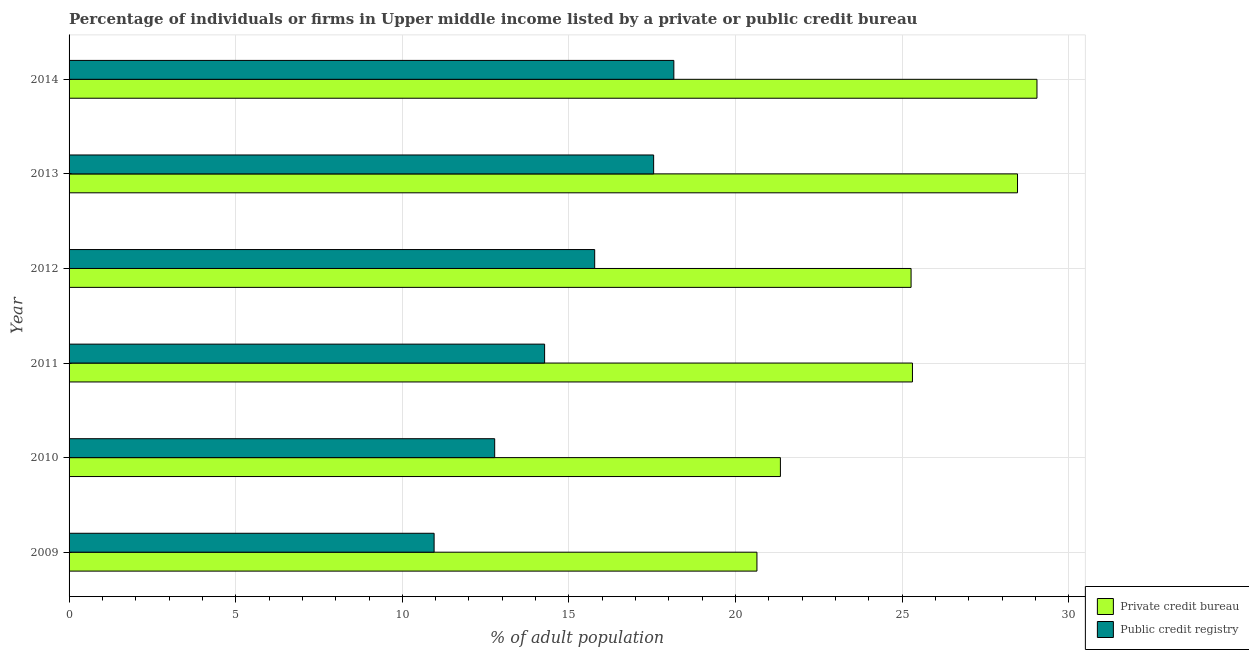How many groups of bars are there?
Keep it short and to the point. 6. Are the number of bars per tick equal to the number of legend labels?
Give a very brief answer. Yes. Are the number of bars on each tick of the Y-axis equal?
Your response must be concise. Yes. How many bars are there on the 6th tick from the top?
Your answer should be very brief. 2. How many bars are there on the 4th tick from the bottom?
Ensure brevity in your answer.  2. What is the label of the 1st group of bars from the top?
Provide a succinct answer. 2014. In how many cases, is the number of bars for a given year not equal to the number of legend labels?
Offer a terse response. 0. What is the percentage of firms listed by public credit bureau in 2014?
Give a very brief answer. 18.15. Across all years, what is the maximum percentage of firms listed by private credit bureau?
Keep it short and to the point. 29.04. Across all years, what is the minimum percentage of firms listed by private credit bureau?
Make the answer very short. 20.64. What is the total percentage of firms listed by public credit bureau in the graph?
Offer a terse response. 89.45. What is the difference between the percentage of firms listed by private credit bureau in 2010 and that in 2012?
Give a very brief answer. -3.92. What is the difference between the percentage of firms listed by private credit bureau in 2009 and the percentage of firms listed by public credit bureau in 2014?
Give a very brief answer. 2.49. What is the average percentage of firms listed by public credit bureau per year?
Your answer should be compact. 14.91. In the year 2010, what is the difference between the percentage of firms listed by public credit bureau and percentage of firms listed by private credit bureau?
Ensure brevity in your answer.  -8.57. In how many years, is the percentage of firms listed by public credit bureau greater than 9 %?
Offer a terse response. 6. What is the difference between the highest and the second highest percentage of firms listed by private credit bureau?
Offer a terse response. 0.58. What is the difference between the highest and the lowest percentage of firms listed by public credit bureau?
Your response must be concise. 7.19. Is the sum of the percentage of firms listed by public credit bureau in 2011 and 2013 greater than the maximum percentage of firms listed by private credit bureau across all years?
Your answer should be very brief. Yes. What does the 1st bar from the top in 2012 represents?
Provide a succinct answer. Public credit registry. What does the 1st bar from the bottom in 2011 represents?
Your answer should be very brief. Private credit bureau. How many bars are there?
Offer a terse response. 12. How many years are there in the graph?
Keep it short and to the point. 6. Does the graph contain any zero values?
Your answer should be compact. No. Where does the legend appear in the graph?
Offer a terse response. Bottom right. How many legend labels are there?
Offer a very short reply. 2. How are the legend labels stacked?
Keep it short and to the point. Vertical. What is the title of the graph?
Your answer should be very brief. Percentage of individuals or firms in Upper middle income listed by a private or public credit bureau. What is the label or title of the X-axis?
Your answer should be very brief. % of adult population. What is the label or title of the Y-axis?
Offer a very short reply. Year. What is the % of adult population in Private credit bureau in 2009?
Your answer should be compact. 20.64. What is the % of adult population of Public credit registry in 2009?
Make the answer very short. 10.95. What is the % of adult population in Private credit bureau in 2010?
Your response must be concise. 21.34. What is the % of adult population in Public credit registry in 2010?
Offer a terse response. 12.77. What is the % of adult population in Private credit bureau in 2011?
Ensure brevity in your answer.  25.31. What is the % of adult population in Public credit registry in 2011?
Keep it short and to the point. 14.27. What is the % of adult population of Private credit bureau in 2012?
Your response must be concise. 25.27. What is the % of adult population of Public credit registry in 2012?
Offer a very short reply. 15.77. What is the % of adult population of Private credit bureau in 2013?
Provide a short and direct response. 28.46. What is the % of adult population of Public credit registry in 2013?
Offer a very short reply. 17.54. What is the % of adult population of Private credit bureau in 2014?
Give a very brief answer. 29.04. What is the % of adult population of Public credit registry in 2014?
Your response must be concise. 18.15. Across all years, what is the maximum % of adult population in Private credit bureau?
Keep it short and to the point. 29.04. Across all years, what is the maximum % of adult population in Public credit registry?
Give a very brief answer. 18.15. Across all years, what is the minimum % of adult population of Private credit bureau?
Your answer should be compact. 20.64. Across all years, what is the minimum % of adult population of Public credit registry?
Keep it short and to the point. 10.95. What is the total % of adult population in Private credit bureau in the graph?
Give a very brief answer. 150.06. What is the total % of adult population of Public credit registry in the graph?
Your answer should be very brief. 89.45. What is the difference between the % of adult population in Private credit bureau in 2009 and that in 2010?
Your answer should be compact. -0.7. What is the difference between the % of adult population of Public credit registry in 2009 and that in 2010?
Give a very brief answer. -1.82. What is the difference between the % of adult population of Private credit bureau in 2009 and that in 2011?
Ensure brevity in your answer.  -4.67. What is the difference between the % of adult population in Public credit registry in 2009 and that in 2011?
Your answer should be compact. -3.32. What is the difference between the % of adult population of Private credit bureau in 2009 and that in 2012?
Keep it short and to the point. -4.63. What is the difference between the % of adult population of Public credit registry in 2009 and that in 2012?
Offer a terse response. -4.82. What is the difference between the % of adult population of Private credit bureau in 2009 and that in 2013?
Your answer should be compact. -7.82. What is the difference between the % of adult population in Public credit registry in 2009 and that in 2013?
Offer a very short reply. -6.59. What is the difference between the % of adult population in Private credit bureau in 2009 and that in 2014?
Make the answer very short. -8.4. What is the difference between the % of adult population of Public credit registry in 2009 and that in 2014?
Give a very brief answer. -7.19. What is the difference between the % of adult population of Private credit bureau in 2010 and that in 2011?
Your response must be concise. -3.96. What is the difference between the % of adult population of Public credit registry in 2010 and that in 2011?
Give a very brief answer. -1.5. What is the difference between the % of adult population of Private credit bureau in 2010 and that in 2012?
Provide a succinct answer. -3.92. What is the difference between the % of adult population of Public credit registry in 2010 and that in 2012?
Your response must be concise. -3. What is the difference between the % of adult population in Private credit bureau in 2010 and that in 2013?
Ensure brevity in your answer.  -7.11. What is the difference between the % of adult population of Public credit registry in 2010 and that in 2013?
Provide a succinct answer. -4.77. What is the difference between the % of adult population in Private credit bureau in 2010 and that in 2014?
Keep it short and to the point. -7.7. What is the difference between the % of adult population of Public credit registry in 2010 and that in 2014?
Make the answer very short. -5.38. What is the difference between the % of adult population of Private credit bureau in 2011 and that in 2012?
Your response must be concise. 0.04. What is the difference between the % of adult population in Public credit registry in 2011 and that in 2012?
Make the answer very short. -1.5. What is the difference between the % of adult population in Private credit bureau in 2011 and that in 2013?
Your answer should be very brief. -3.15. What is the difference between the % of adult population of Public credit registry in 2011 and that in 2013?
Your answer should be compact. -3.27. What is the difference between the % of adult population in Private credit bureau in 2011 and that in 2014?
Provide a short and direct response. -3.74. What is the difference between the % of adult population in Public credit registry in 2011 and that in 2014?
Keep it short and to the point. -3.88. What is the difference between the % of adult population of Private credit bureau in 2012 and that in 2013?
Provide a short and direct response. -3.19. What is the difference between the % of adult population of Public credit registry in 2012 and that in 2013?
Give a very brief answer. -1.77. What is the difference between the % of adult population of Private credit bureau in 2012 and that in 2014?
Provide a succinct answer. -3.78. What is the difference between the % of adult population of Public credit registry in 2012 and that in 2014?
Offer a very short reply. -2.38. What is the difference between the % of adult population of Private credit bureau in 2013 and that in 2014?
Your response must be concise. -0.58. What is the difference between the % of adult population in Public credit registry in 2013 and that in 2014?
Make the answer very short. -0.61. What is the difference between the % of adult population of Private credit bureau in 2009 and the % of adult population of Public credit registry in 2010?
Provide a short and direct response. 7.87. What is the difference between the % of adult population in Private credit bureau in 2009 and the % of adult population in Public credit registry in 2011?
Offer a terse response. 6.37. What is the difference between the % of adult population in Private credit bureau in 2009 and the % of adult population in Public credit registry in 2012?
Your answer should be very brief. 4.87. What is the difference between the % of adult population in Private credit bureau in 2009 and the % of adult population in Public credit registry in 2013?
Your response must be concise. 3.1. What is the difference between the % of adult population in Private credit bureau in 2009 and the % of adult population in Public credit registry in 2014?
Provide a short and direct response. 2.49. What is the difference between the % of adult population in Private credit bureau in 2010 and the % of adult population in Public credit registry in 2011?
Keep it short and to the point. 7.08. What is the difference between the % of adult population of Private credit bureau in 2010 and the % of adult population of Public credit registry in 2012?
Offer a terse response. 5.57. What is the difference between the % of adult population in Private credit bureau in 2010 and the % of adult population in Public credit registry in 2013?
Your response must be concise. 3.8. What is the difference between the % of adult population in Private credit bureau in 2010 and the % of adult population in Public credit registry in 2014?
Your answer should be compact. 3.2. What is the difference between the % of adult population in Private credit bureau in 2011 and the % of adult population in Public credit registry in 2012?
Your answer should be very brief. 9.53. What is the difference between the % of adult population in Private credit bureau in 2011 and the % of adult population in Public credit registry in 2013?
Keep it short and to the point. 7.77. What is the difference between the % of adult population of Private credit bureau in 2011 and the % of adult population of Public credit registry in 2014?
Your response must be concise. 7.16. What is the difference between the % of adult population in Private credit bureau in 2012 and the % of adult population in Public credit registry in 2013?
Keep it short and to the point. 7.72. What is the difference between the % of adult population in Private credit bureau in 2012 and the % of adult population in Public credit registry in 2014?
Keep it short and to the point. 7.12. What is the difference between the % of adult population in Private credit bureau in 2013 and the % of adult population in Public credit registry in 2014?
Offer a terse response. 10.31. What is the average % of adult population of Private credit bureau per year?
Ensure brevity in your answer.  25.01. What is the average % of adult population of Public credit registry per year?
Provide a succinct answer. 14.91. In the year 2009, what is the difference between the % of adult population in Private credit bureau and % of adult population in Public credit registry?
Your response must be concise. 9.69. In the year 2010, what is the difference between the % of adult population of Private credit bureau and % of adult population of Public credit registry?
Give a very brief answer. 8.57. In the year 2011, what is the difference between the % of adult population of Private credit bureau and % of adult population of Public credit registry?
Give a very brief answer. 11.04. In the year 2012, what is the difference between the % of adult population in Private credit bureau and % of adult population in Public credit registry?
Offer a very short reply. 9.49. In the year 2013, what is the difference between the % of adult population in Private credit bureau and % of adult population in Public credit registry?
Your response must be concise. 10.92. In the year 2014, what is the difference between the % of adult population of Private credit bureau and % of adult population of Public credit registry?
Make the answer very short. 10.9. What is the ratio of the % of adult population of Private credit bureau in 2009 to that in 2010?
Ensure brevity in your answer.  0.97. What is the ratio of the % of adult population of Public credit registry in 2009 to that in 2010?
Keep it short and to the point. 0.86. What is the ratio of the % of adult population of Private credit bureau in 2009 to that in 2011?
Your response must be concise. 0.82. What is the ratio of the % of adult population of Public credit registry in 2009 to that in 2011?
Keep it short and to the point. 0.77. What is the ratio of the % of adult population of Private credit bureau in 2009 to that in 2012?
Offer a very short reply. 0.82. What is the ratio of the % of adult population of Public credit registry in 2009 to that in 2012?
Offer a terse response. 0.69. What is the ratio of the % of adult population in Private credit bureau in 2009 to that in 2013?
Make the answer very short. 0.73. What is the ratio of the % of adult population of Public credit registry in 2009 to that in 2013?
Offer a very short reply. 0.62. What is the ratio of the % of adult population of Private credit bureau in 2009 to that in 2014?
Offer a terse response. 0.71. What is the ratio of the % of adult population of Public credit registry in 2009 to that in 2014?
Provide a succinct answer. 0.6. What is the ratio of the % of adult population in Private credit bureau in 2010 to that in 2011?
Your response must be concise. 0.84. What is the ratio of the % of adult population in Public credit registry in 2010 to that in 2011?
Make the answer very short. 0.9. What is the ratio of the % of adult population in Private credit bureau in 2010 to that in 2012?
Make the answer very short. 0.84. What is the ratio of the % of adult population in Public credit registry in 2010 to that in 2012?
Give a very brief answer. 0.81. What is the ratio of the % of adult population of Public credit registry in 2010 to that in 2013?
Provide a succinct answer. 0.73. What is the ratio of the % of adult population in Private credit bureau in 2010 to that in 2014?
Ensure brevity in your answer.  0.73. What is the ratio of the % of adult population of Public credit registry in 2010 to that in 2014?
Keep it short and to the point. 0.7. What is the ratio of the % of adult population in Public credit registry in 2011 to that in 2012?
Ensure brevity in your answer.  0.9. What is the ratio of the % of adult population in Private credit bureau in 2011 to that in 2013?
Your answer should be very brief. 0.89. What is the ratio of the % of adult population of Public credit registry in 2011 to that in 2013?
Keep it short and to the point. 0.81. What is the ratio of the % of adult population in Private credit bureau in 2011 to that in 2014?
Offer a very short reply. 0.87. What is the ratio of the % of adult population of Public credit registry in 2011 to that in 2014?
Offer a terse response. 0.79. What is the ratio of the % of adult population of Private credit bureau in 2012 to that in 2013?
Keep it short and to the point. 0.89. What is the ratio of the % of adult population in Public credit registry in 2012 to that in 2013?
Your answer should be very brief. 0.9. What is the ratio of the % of adult population in Private credit bureau in 2012 to that in 2014?
Offer a very short reply. 0.87. What is the ratio of the % of adult population of Public credit registry in 2012 to that in 2014?
Give a very brief answer. 0.87. What is the ratio of the % of adult population of Private credit bureau in 2013 to that in 2014?
Your response must be concise. 0.98. What is the ratio of the % of adult population of Public credit registry in 2013 to that in 2014?
Provide a succinct answer. 0.97. What is the difference between the highest and the second highest % of adult population of Private credit bureau?
Your answer should be compact. 0.58. What is the difference between the highest and the second highest % of adult population of Public credit registry?
Ensure brevity in your answer.  0.61. What is the difference between the highest and the lowest % of adult population of Private credit bureau?
Provide a succinct answer. 8.4. What is the difference between the highest and the lowest % of adult population in Public credit registry?
Offer a terse response. 7.19. 